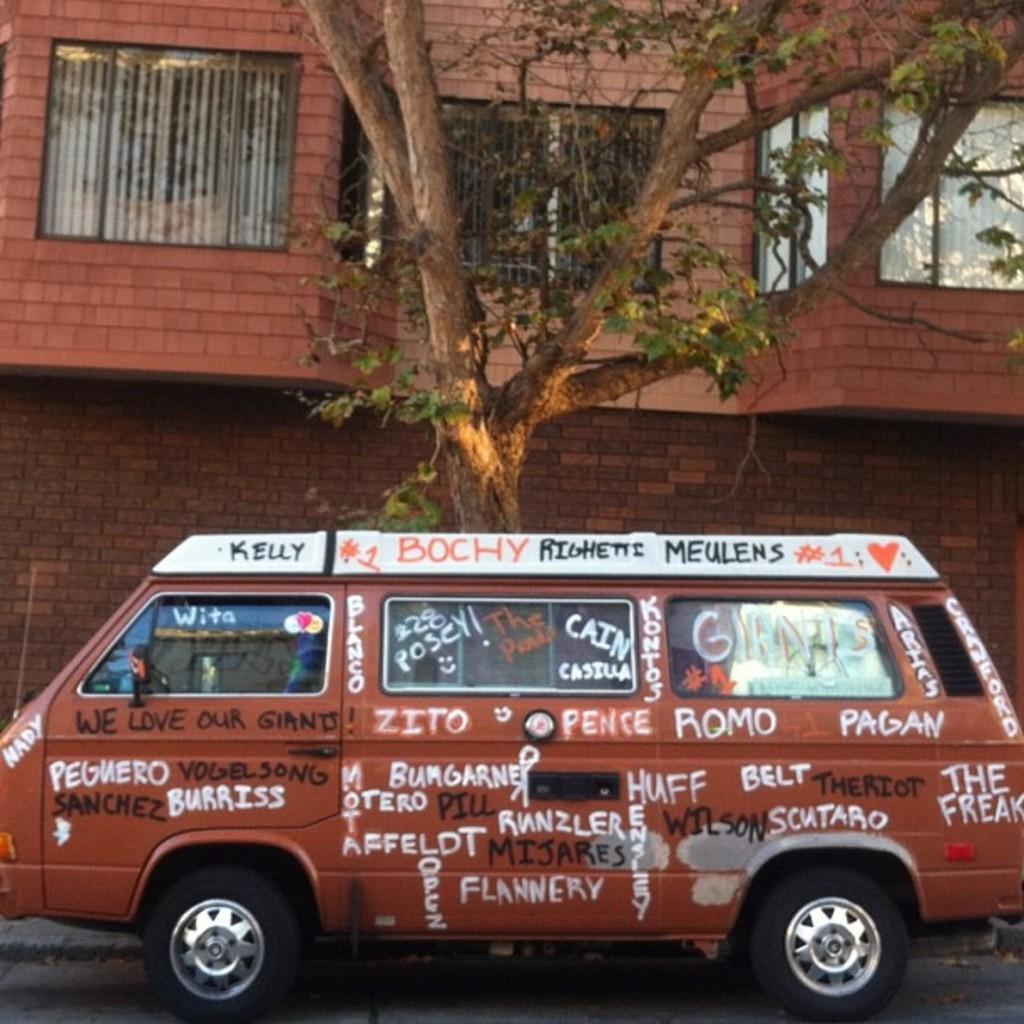What type of vehicle is in the image? There is a van in the image. Where is the van located in relation to other objects? The van is parked near a tree. What can be seen on the van? There is writing on the van. What is visible in the background of the image? There is a building in the background of the image. What feature of the building is mentioned in the facts? The building has windows. How many horses can be seen drinking from a can near the van in the image? There are no horses or cans present in the image. 